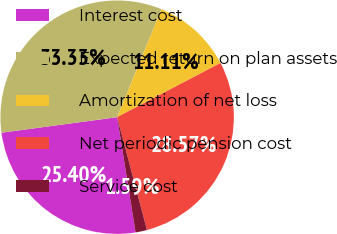<chart> <loc_0><loc_0><loc_500><loc_500><pie_chart><fcel>Interest cost<fcel>Expected return on plan assets<fcel>Amortization of net loss<fcel>Net periodic pension cost<fcel>Service cost<nl><fcel>25.4%<fcel>33.33%<fcel>11.11%<fcel>28.57%<fcel>1.59%<nl></chart> 